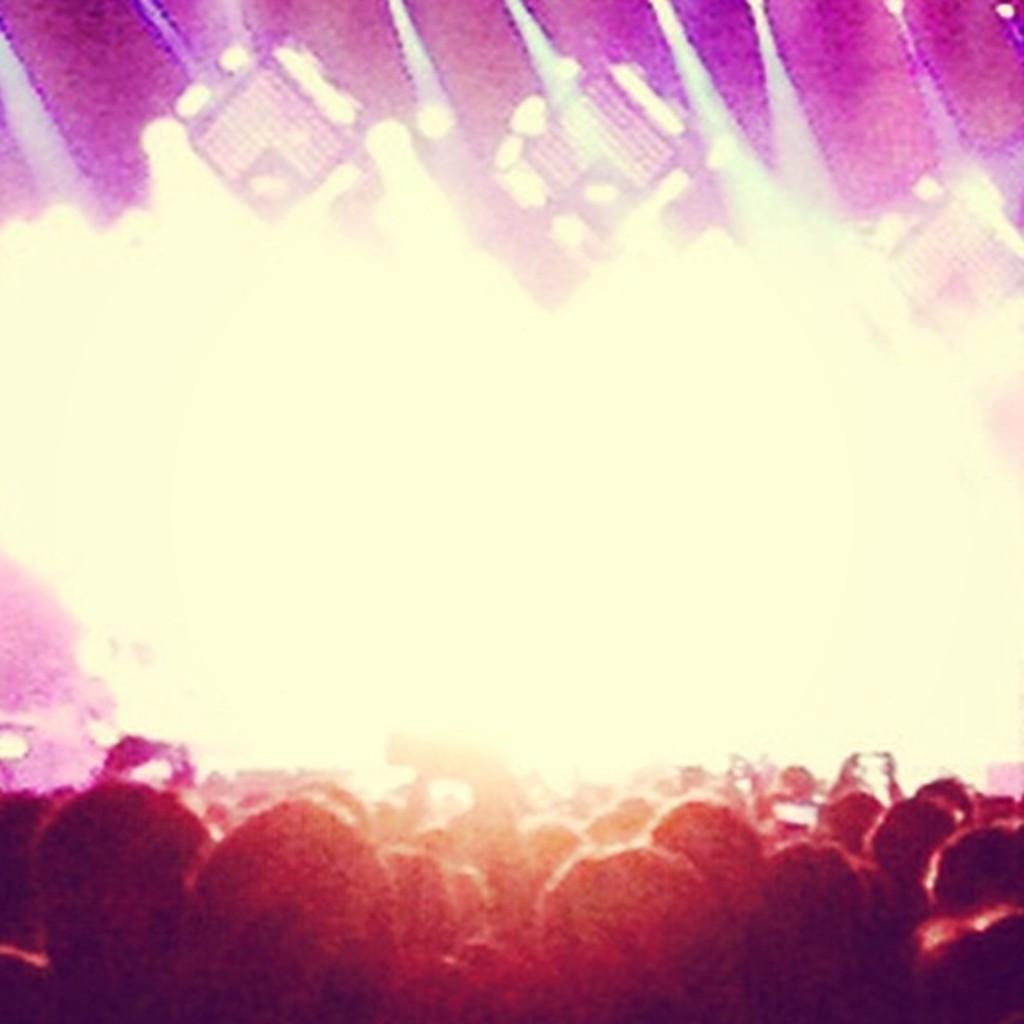How would you summarize this image in a sentence or two? In the foreground of the image we can see group of people standing. One person is holding a mobile in his hand. In the background, we can see some lights. 